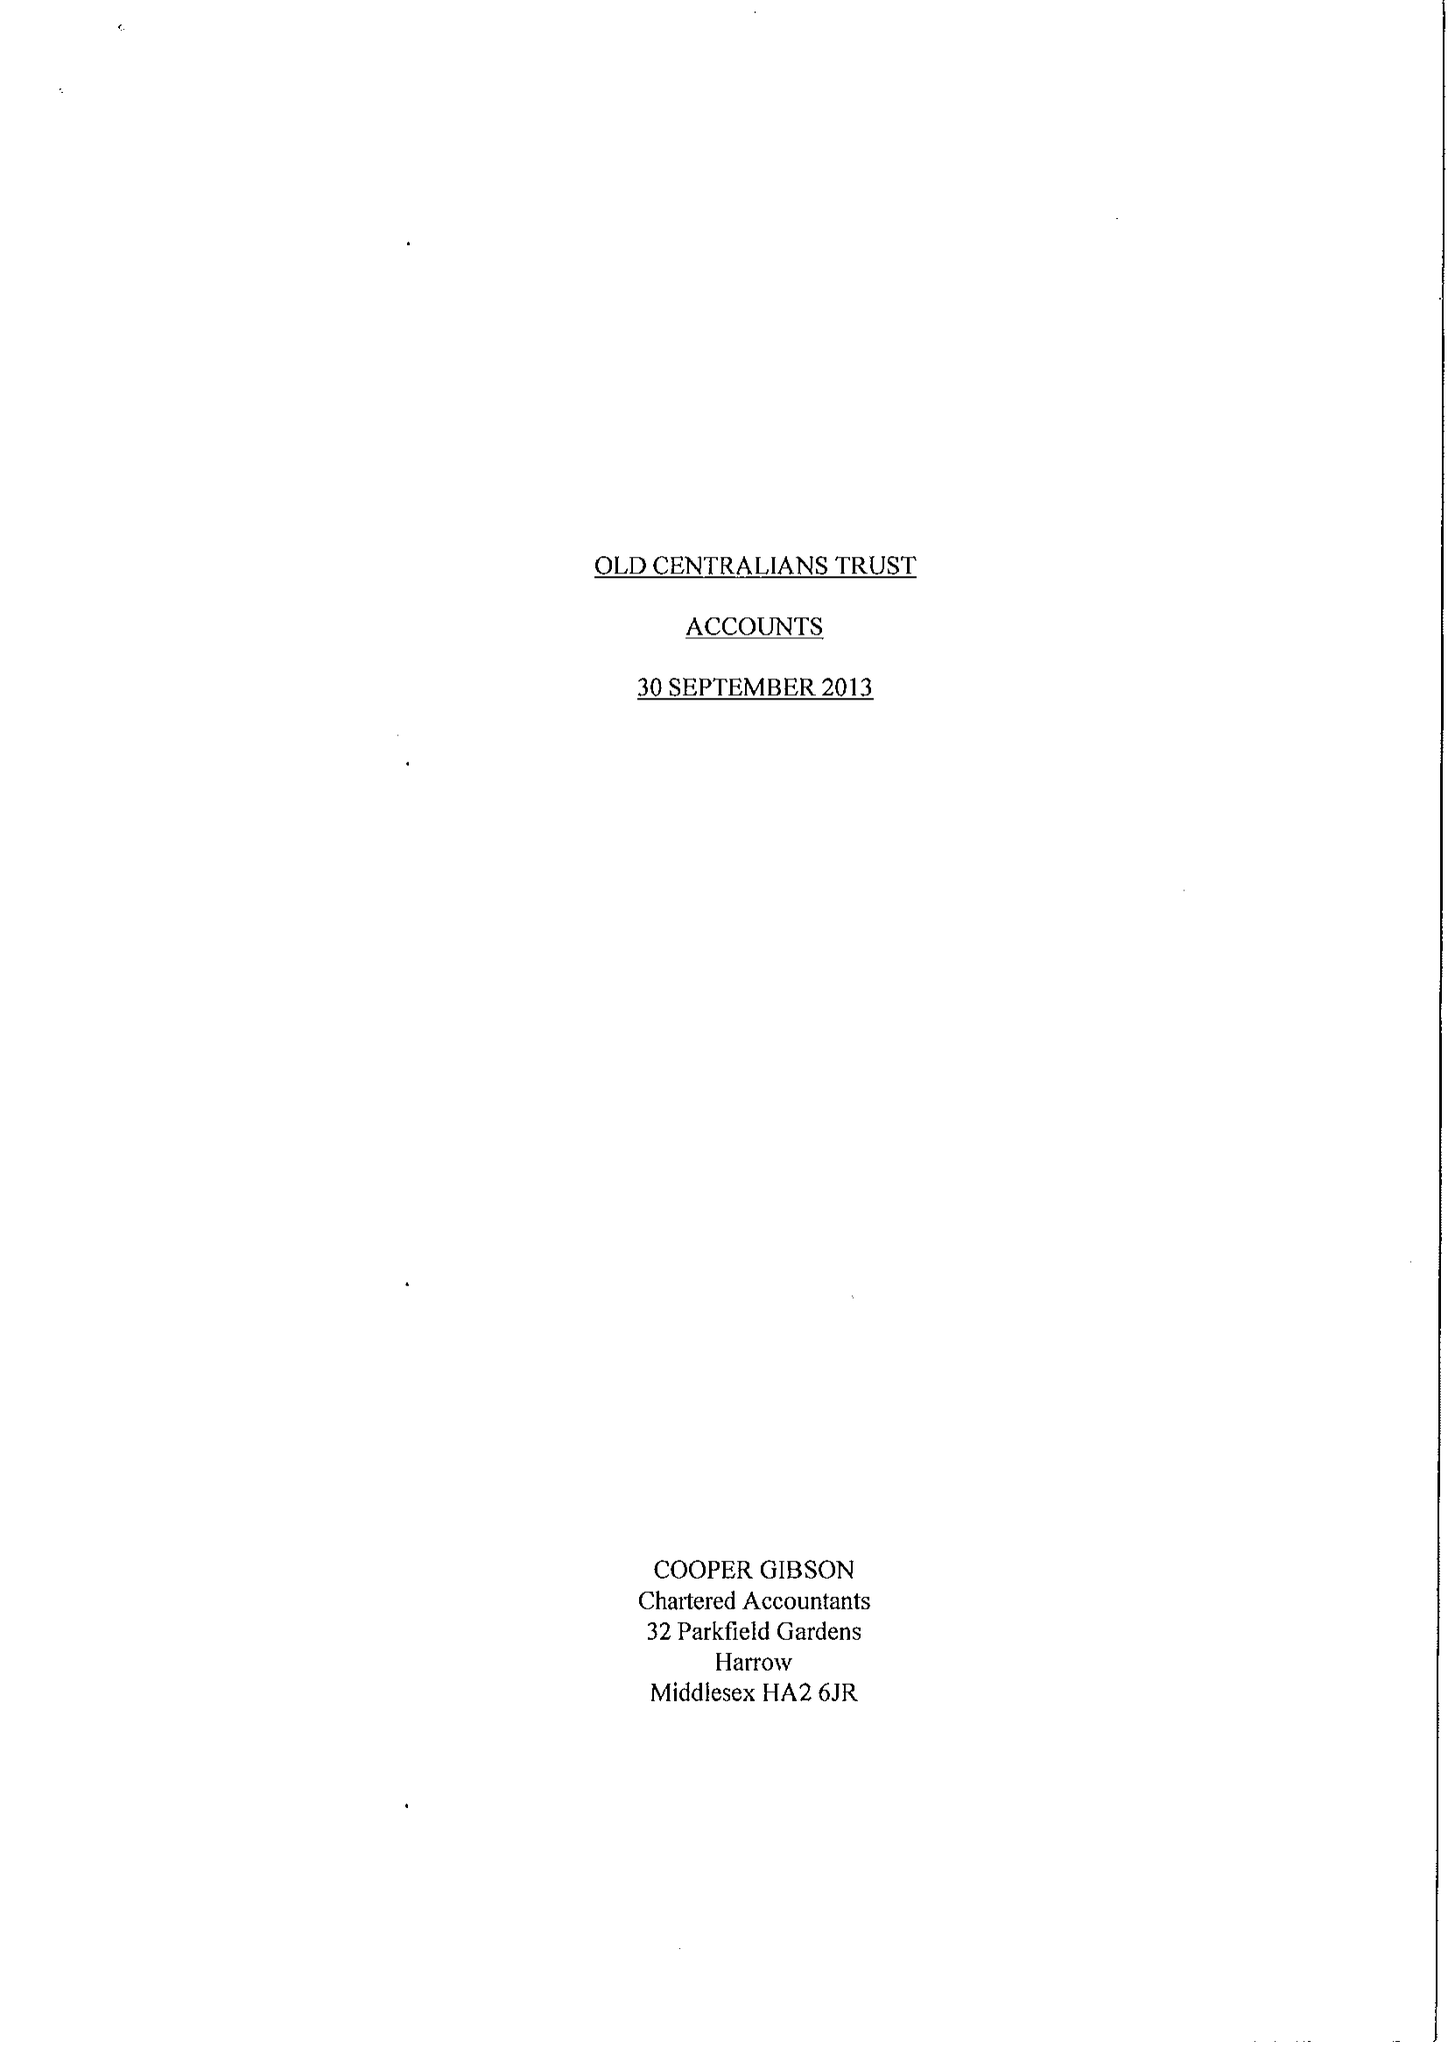What is the value for the spending_annually_in_british_pounds?
Answer the question using a single word or phrase. 50544.00 